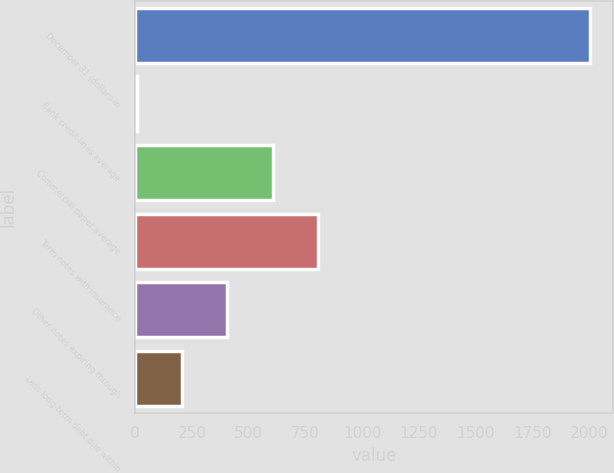Convert chart. <chart><loc_0><loc_0><loc_500><loc_500><bar_chart><fcel>December 31 (dollars in<fcel>Bank credit lines average<fcel>Commercial paper average<fcel>Term notes with insurance<fcel>Other notes expiring through<fcel>Less long-term debt due within<nl><fcel>2003<fcel>6.5<fcel>605.45<fcel>805.1<fcel>405.8<fcel>206.15<nl></chart> 